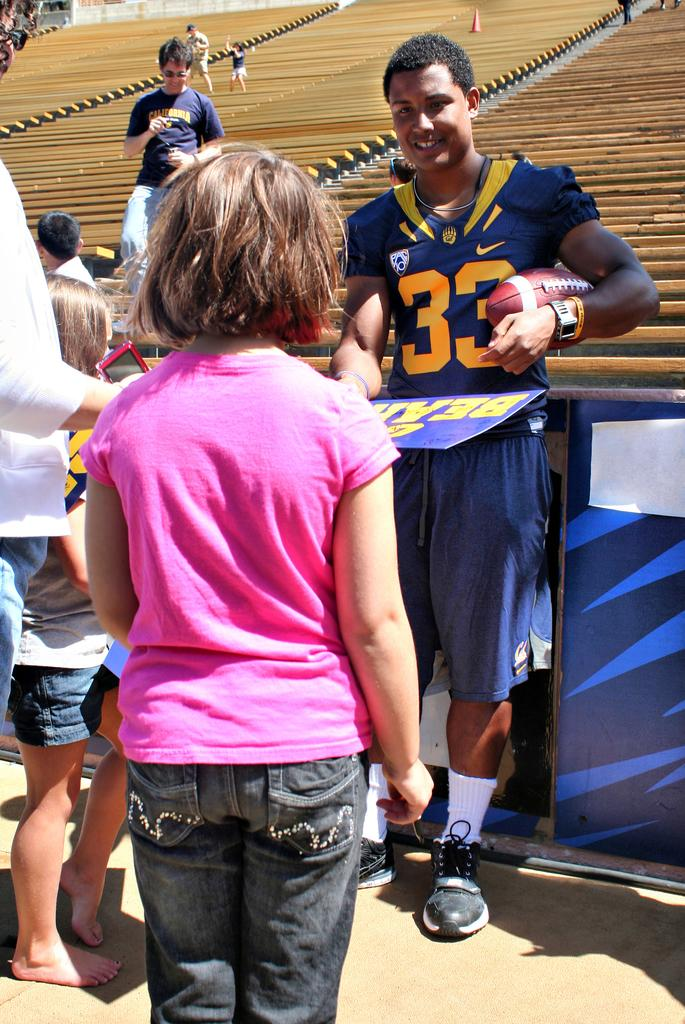<image>
Write a terse but informative summary of the picture. The player standing infront of the fans wears number 33 on their top. 